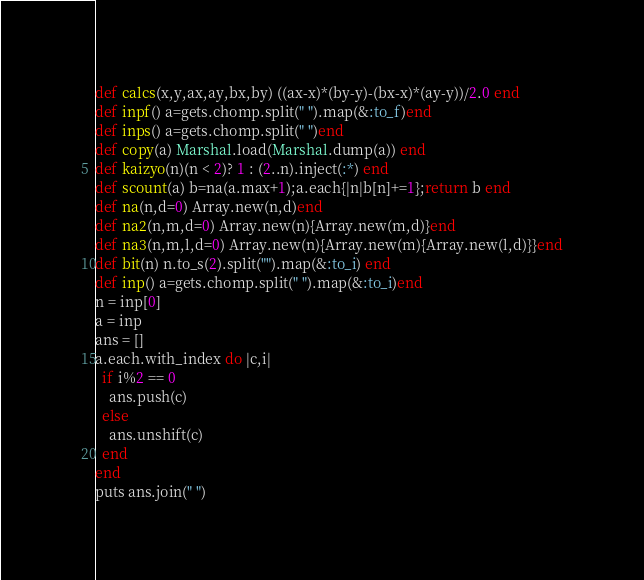<code> <loc_0><loc_0><loc_500><loc_500><_Ruby_>def calcs(x,y,ax,ay,bx,by) ((ax-x)*(by-y)-(bx-x)*(ay-y))/2.0 end
def inpf() a=gets.chomp.split(" ").map(&:to_f)end
def inps() a=gets.chomp.split(" ")end  
def copy(a) Marshal.load(Marshal.dump(a)) end
def kaizyo(n)(n < 2)? 1 : (2..n).inject(:*) end
def scount(a) b=na(a.max+1);a.each{|n|b[n]+=1};return b end
def na(n,d=0) Array.new(n,d)end
def na2(n,m,d=0) Array.new(n){Array.new(m,d)}end
def na3(n,m,l,d=0) Array.new(n){Array.new(m){Array.new(l,d)}}end
def bit(n) n.to_s(2).split("").map(&:to_i) end
def inp() a=gets.chomp.split(" ").map(&:to_i)end
n = inp[0]
a = inp
ans = []
a.each.with_index do |c,i|
  if i%2 == 0
    ans.push(c)
  else
    ans.unshift(c)
  end
end
puts ans.join(" ")</code> 